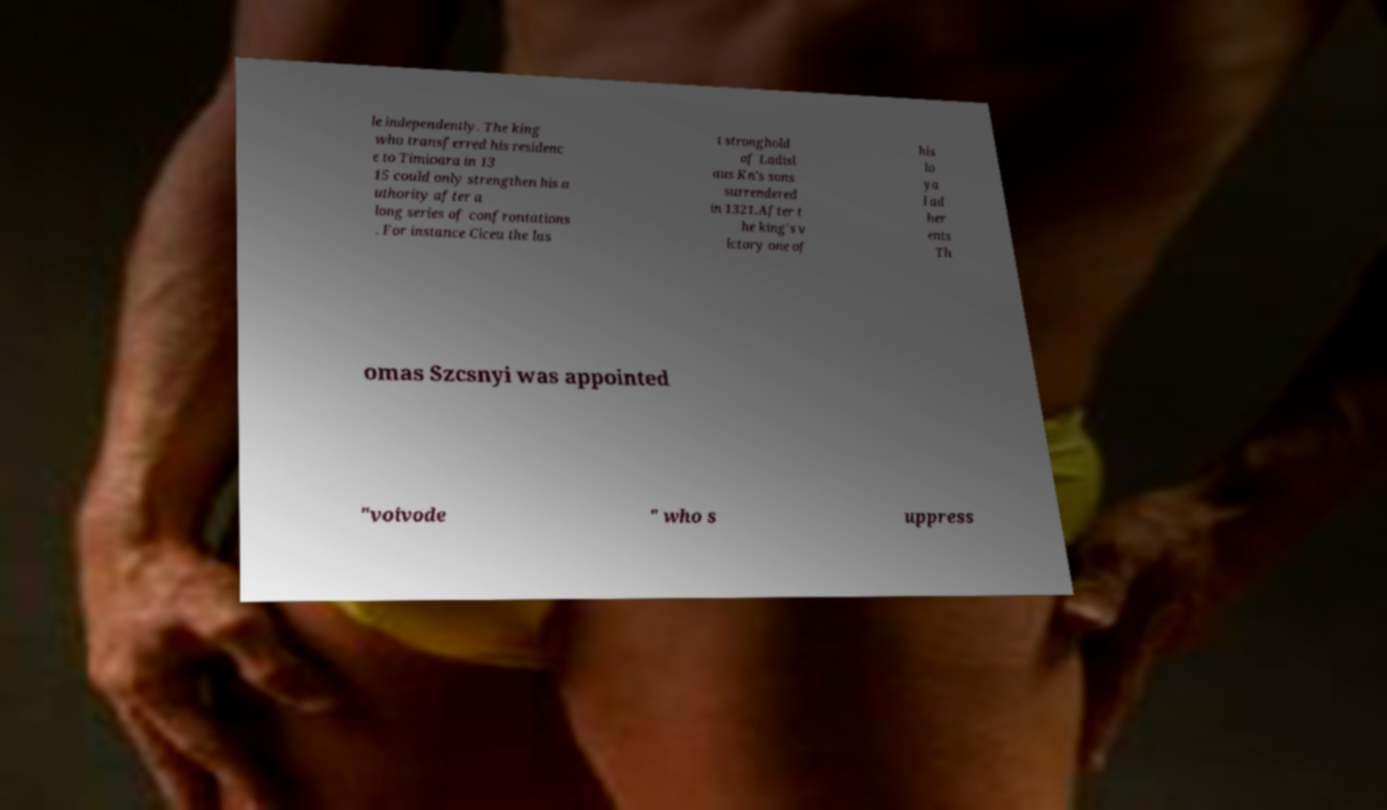Please read and relay the text visible in this image. What does it say? le independently. The king who transferred his residenc e to Timioara in 13 15 could only strengthen his a uthority after a long series of confrontations . For instance Ciceu the las t stronghold of Ladisl aus Kn's sons surrendered in 1321.After t he king's v ictory one of his lo ya l ad her ents Th omas Szcsnyi was appointed "voivode " who s uppress 